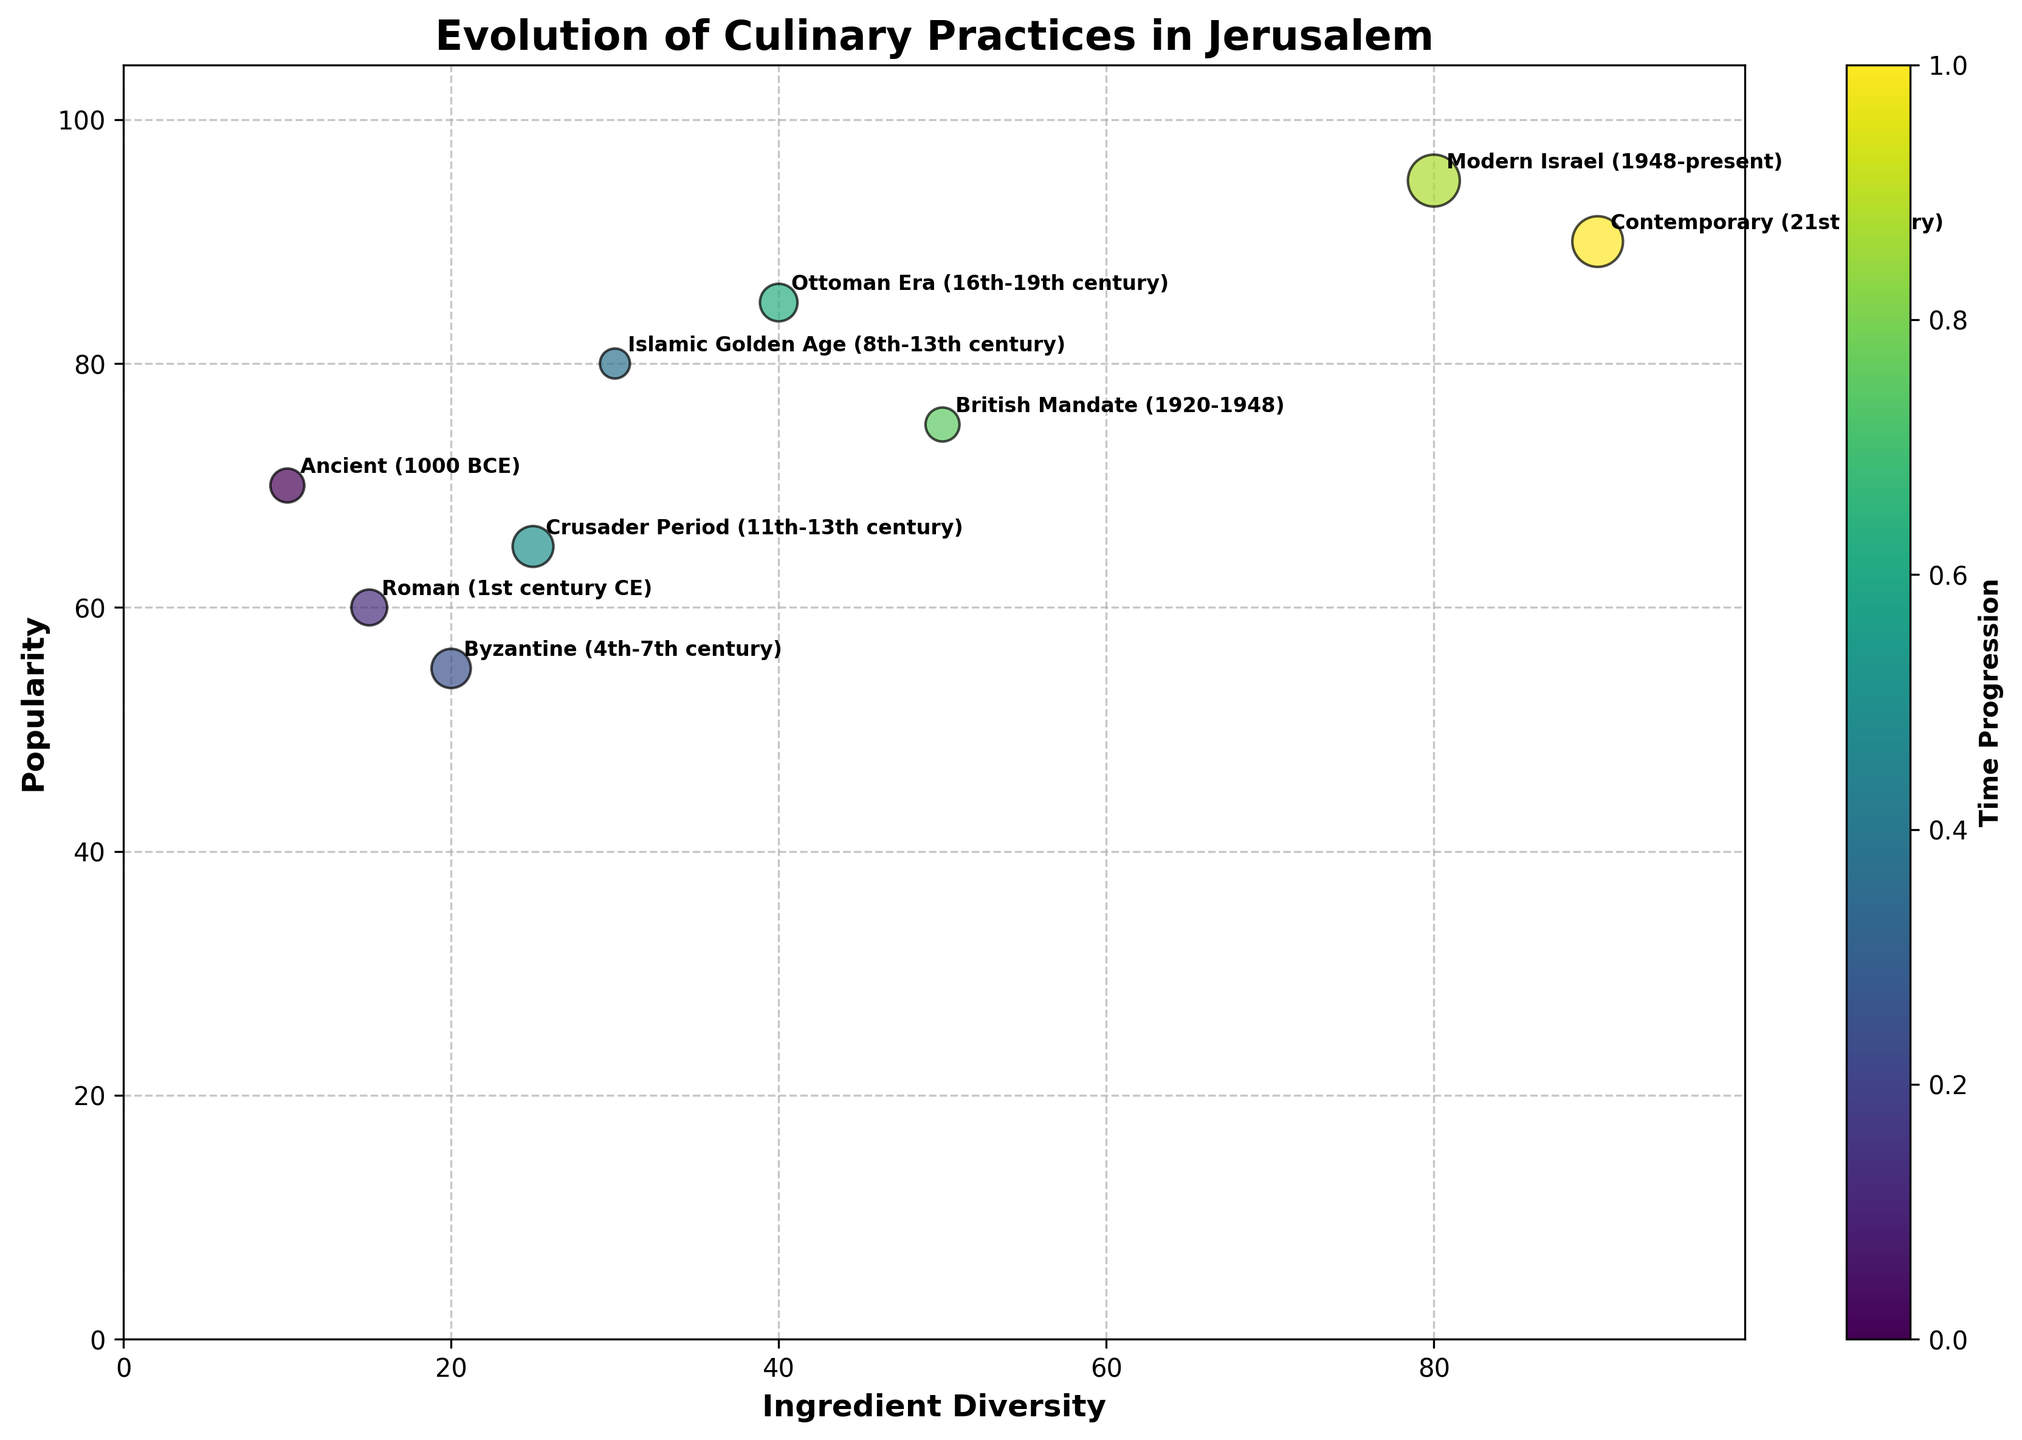what is the title of the figure? The title is usually located at the top of the figure and provides a summary of what the figure represents. In this case, it is specified in the data provided.
Answer: Evolution of Culinary Practices in Jerusalem what data points have an ingredient diversity greater than 50? Look at the x-axis which represents Ingredient Diversity and identify points that fall to the right of 50.
Answer: British Mandate, Modern Israel, Contemporary which era had the highest popularity? The y-axis represents popularity. Identify the data point that is located highest on the y-axis.
Answer: Modern Israel how does the ingredient diversity of the Crusader Period compare with the Islamic Golden Age? Compare Crusader Period’s x-value with Islamic Golden Age’s x-value on the x-axis to see which one is higher.
Answer: Islamic Golden Age has higher ingredient diversity which cooking method is represented by the smallest bubble? Look at the size of the bubbles to identify the smallest one, which corresponds to the length of the cooking method names.
Answer: Open Fire which era shows the largest bubble? Identify the largest bubble in the figure by comparing the sizes visually.
Answer: Molecular Gastronomy how many different eras are represented in the figure? Count the number of unique eras annotated on the figure.
Answer: 9 what is the average ingredient diversity in ancient, Roman, and Byzantine eras? Add the values of Ingredient Diversity for these eras and divide by 3: (10 + 15 + 20) / 3
Answer: 15 which eras have a popularity value between 60 and 80? Identify the data points on the y-axis that fall between 60 and 80.
Answer: Roman, Islamic Golden Age, Crusader Period, British Mandate how has the popularity trend changed from the ancient era to the contemporary era? Observe the general trend of y-values from the leftmost to the rightmost data point.
Answer: Increased over time 